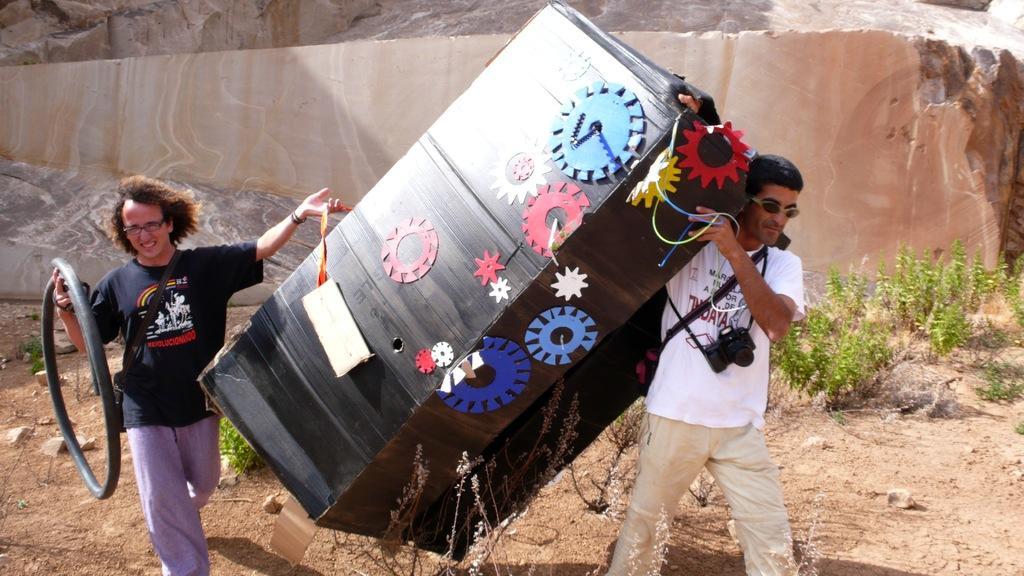In one or two sentences, can you explain what this image depicts? In this image, we can see people and are holding some objects and wearing cameras. In the background, there is a rock and we can see some plants. 